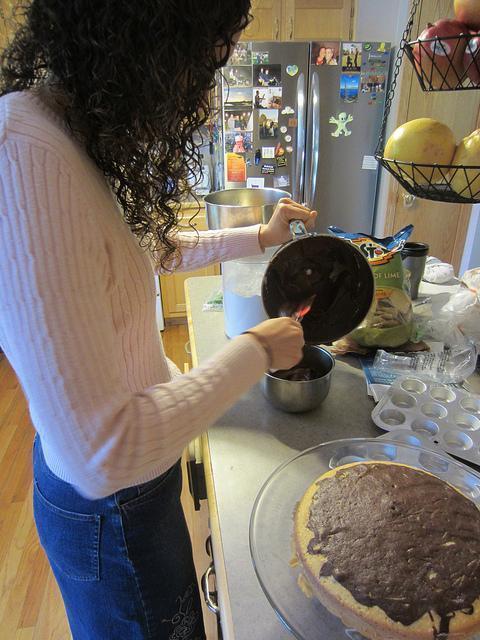How was the item on the plate cooked?
Answer the question by selecting the correct answer among the 4 following choices and explain your choice with a short sentence. The answer should be formatted with the following format: `Answer: choice
Rationale: rationale.`
Options: Microwave, open flame, oven, stovetop. Answer: oven.
Rationale: The item was baked. 